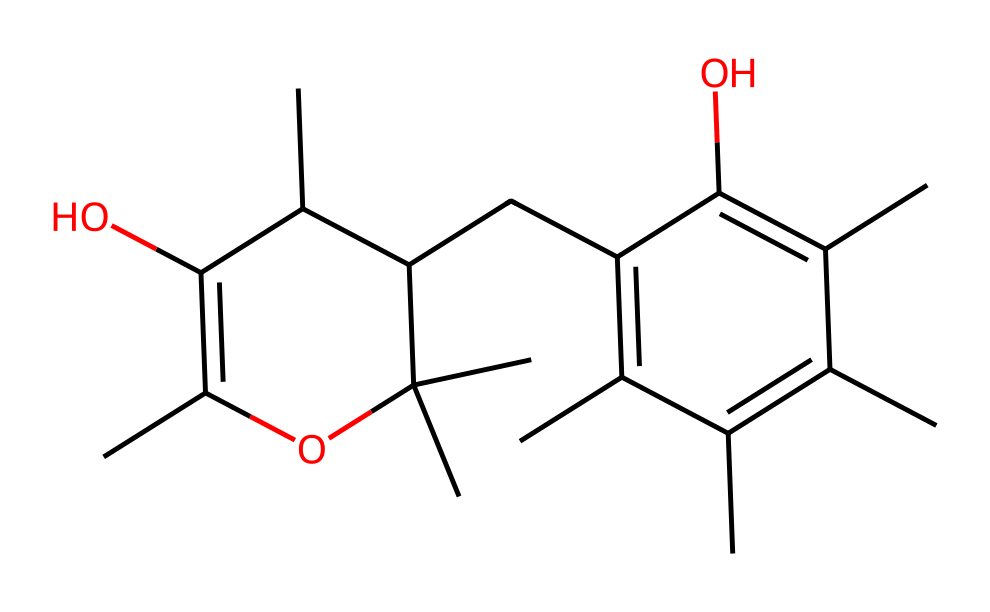What is the molecular formula of vitamin E (alpha-tocopherol)? Counting the carbon (C), hydrogen (H), and oxygen (O) atoms in the SMILES representation reveals that vitamin E has 29 carbon atoms, 50 hydrogen atoms, and 2 oxygen atoms. Therefore, the molecular formula is C29H50O2.
Answer: C29H50O2 How many double bonds are present in the structure of vitamin E? By examining the structure for the presence of double bonds (denoted by "=" in the SMILES), there are three double bonds in the structure of vitamin E.
Answer: 3 What is the significance of the hydroxyl (-OH) group in vitamin E? The hydroxyl group in vitamin E contributes to its antioxidant properties. This functional group allows vitamin E to donate hydrogen atoms to neutralize free radicals, which is crucial for its role in protecting cell membranes.
Answer: antioxidant properties In the context of vitamins, what type does vitamin E belong to? Vitamin E is classified as a fat-soluble vitamin. Such vitamins dissolve in fats and oils, which is indicated by the long hydrocarbon tail present in its structure.
Answer: fat-soluble What role does the unsaturated part of the molecule play in vitamin E's function? The unsaturation in vitamin E's structure enhances its ability to inhibit oxidative processes. The presence of double bonds allows the molecule to react with free radicals, thereby preventing lipid peroxidation and protecting cellular components.
Answer: antioxidant action 